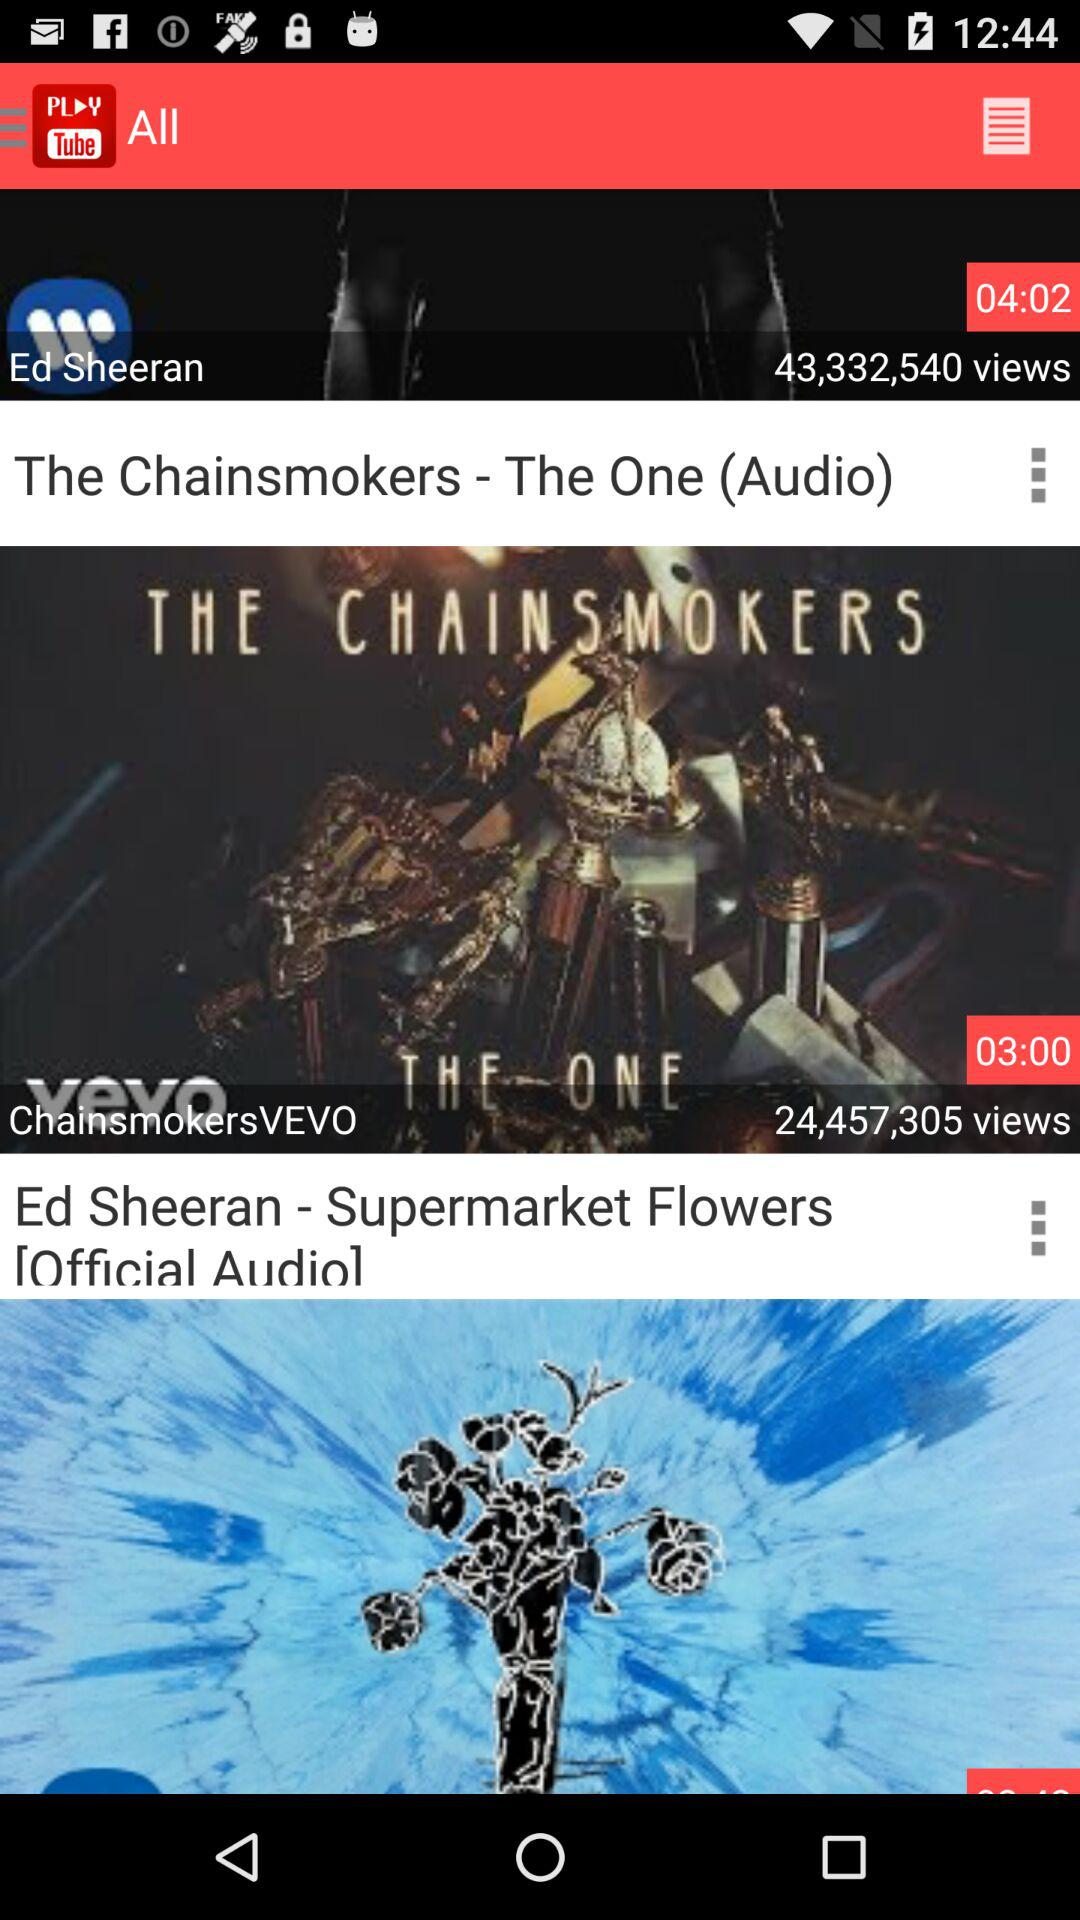What is the duration of the Ed Sheeran audio?
When the provided information is insufficient, respond with <no answer>. <no answer> 